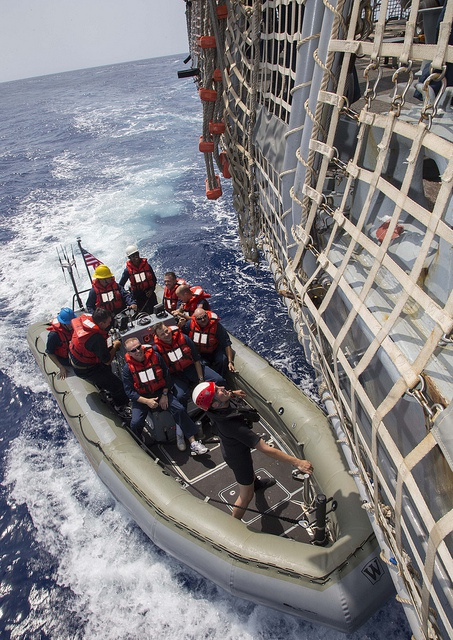Describe the objects in this image and their specific colors. I can see boat in lightgray, darkgray, gray, and black tones, people in lightgray, black, maroon, and gray tones, people in lightgray, black, maroon, and gray tones, and people in lightgray, black, maroon, and gray tones in this image. 